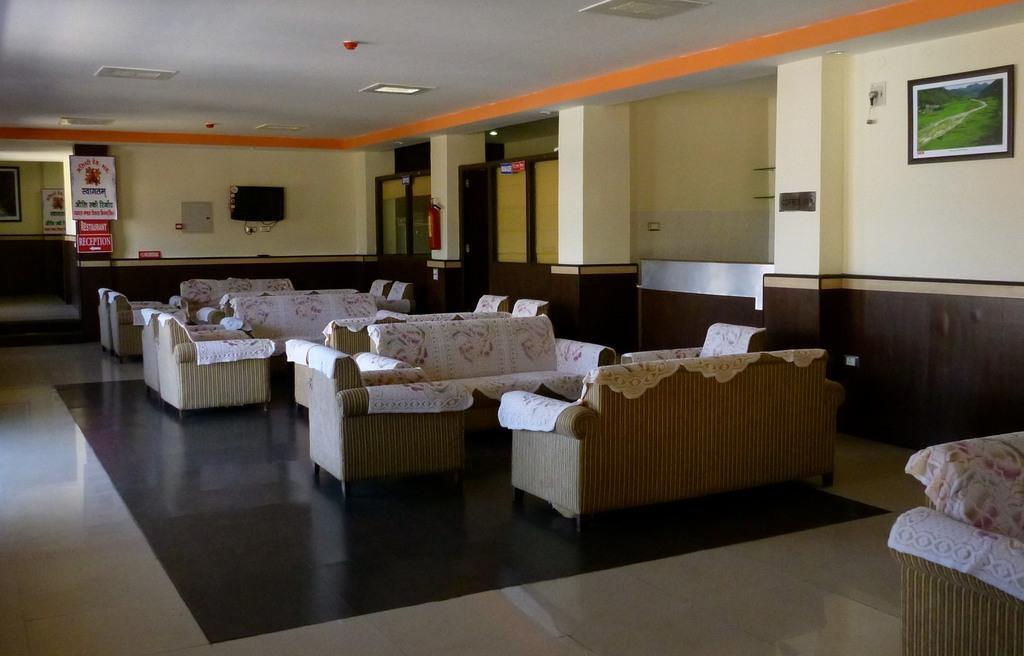How would you summarize this image in a sentence or two? In this image we can see the sofa sets with chairs and covers. We can also see a television, text boards, fire extinguisher and also a frame attached to the wall. At the top there is ceiling with the ceiling lights and at the bottom there is floor. 